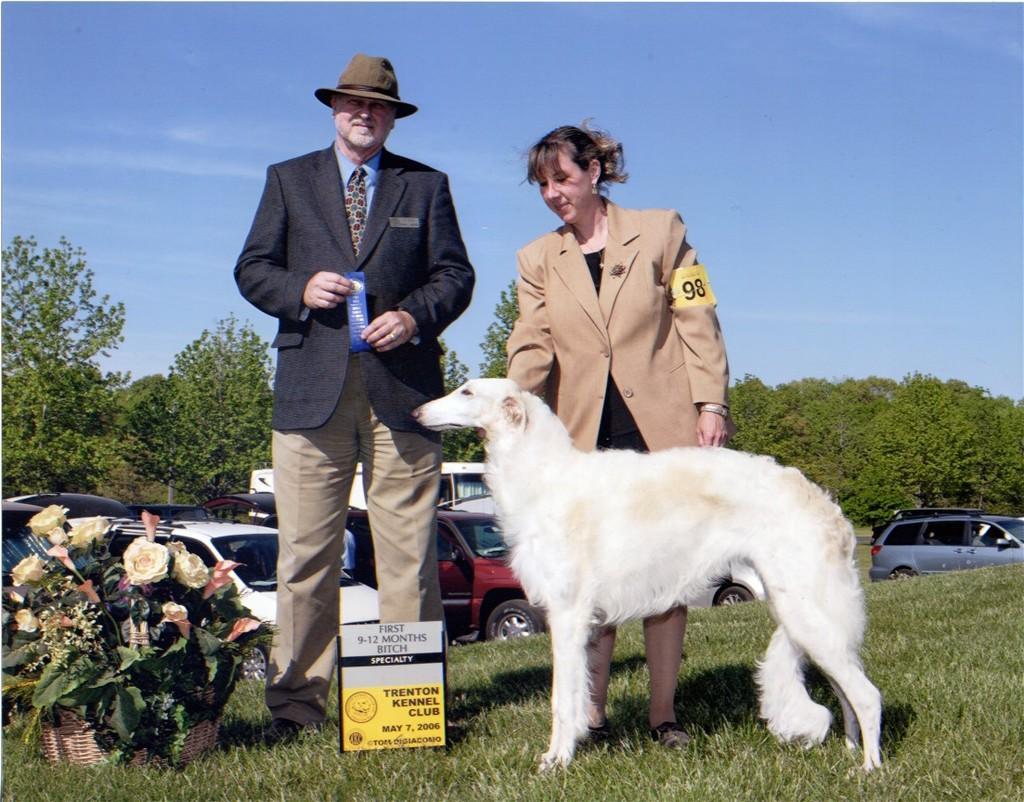Can you describe this image briefly? In this image, we can see an old man in a suit is holding some object and wearing a hat. Beside him, a woman is standing behind the white dog. On the left side, we can see a flower bouquet on the grass. Here there is a board. Background we can see so many vehicles, trees and sky. 